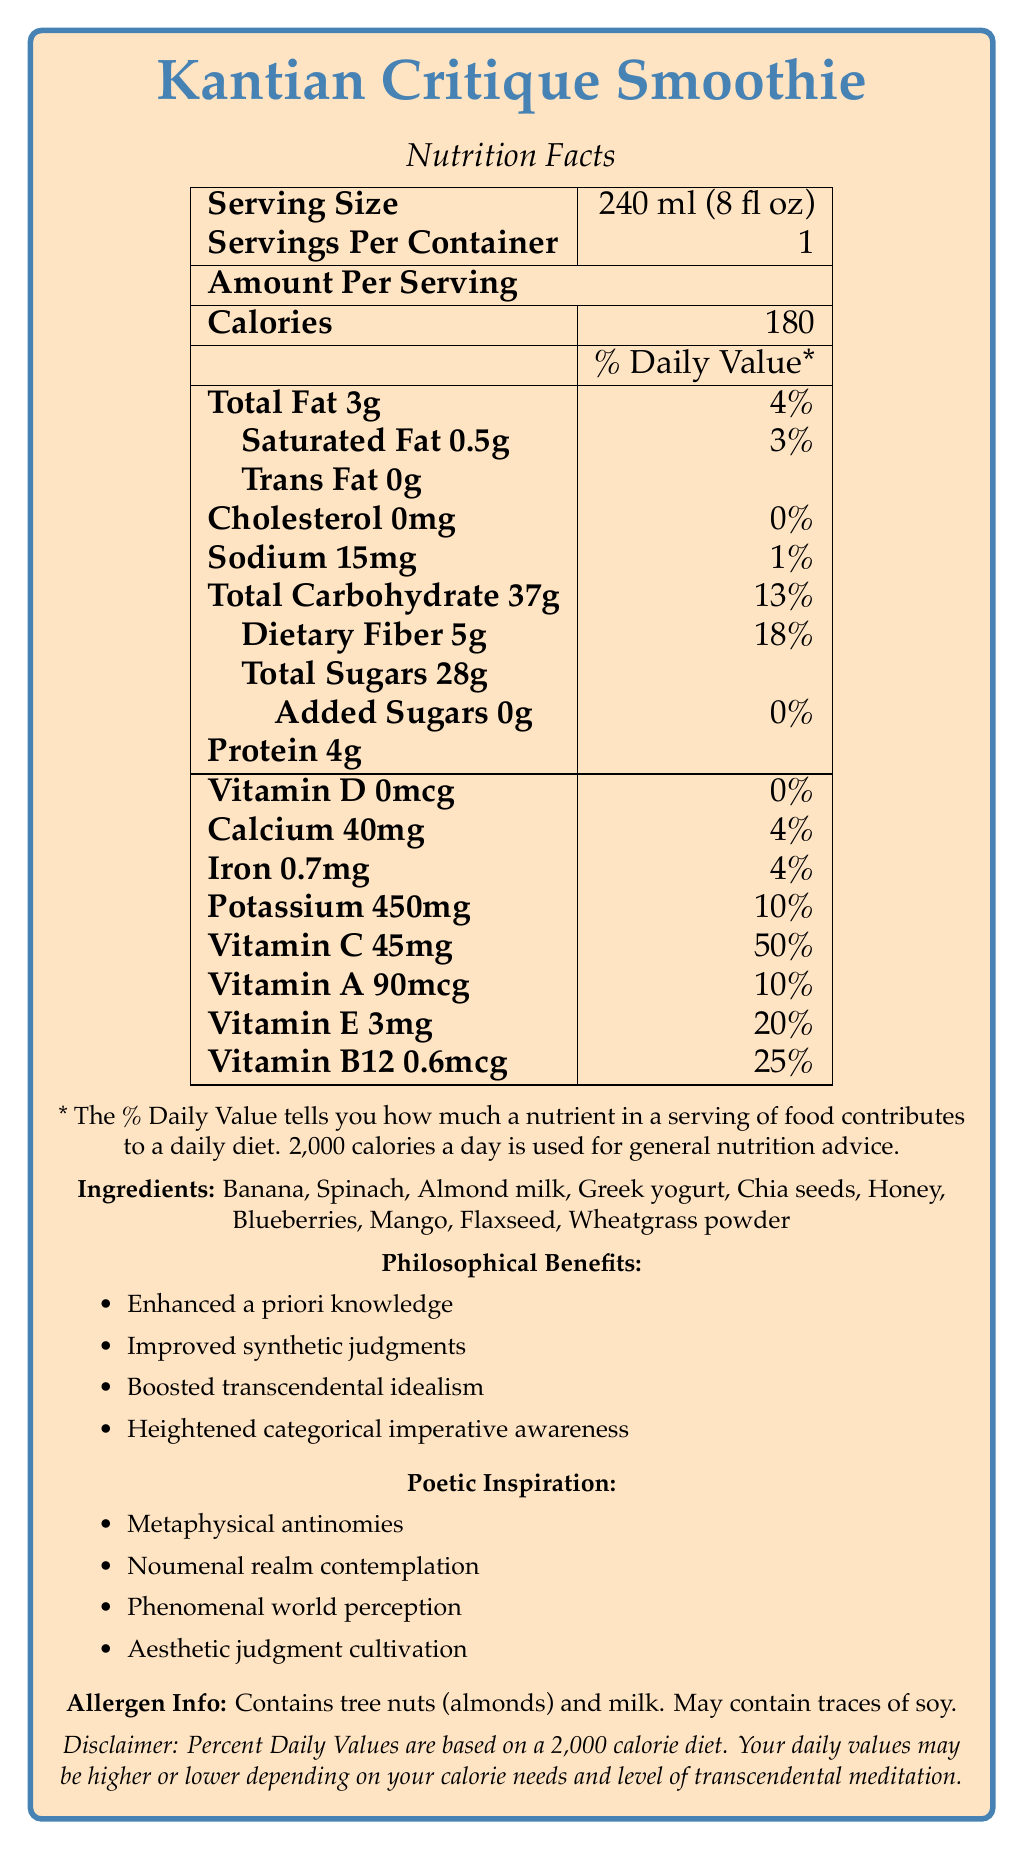What is the serving size of the Kantian Critique Smoothie? The serving size is explicitly listed at the top of the nutrition facts table as "Serving Size: 240 ml (8 fl oz)".
Answer: 240 ml (8 fl oz) How many calories are there per serving? The calories per serving are clearly stated in the nutrition facts as 180.
Answer: 180 Which ingredient contributes to the dietary fiber content? Both chia seeds and flaxseed are known to be high in dietary fiber, and they are listed in the ingredients.
Answer: Chia seeds, Flaxseed What is the daily value percentage of Vitamin C per serving? The daily value percentage of Vitamin C is stated as 50% in the nutrition facts.
Answer: 50% Does the smoothie contain any added sugars? The nutrition facts state the added sugars amount as "0g" and daily value as "0%", thus confirming there are no added sugars.
Answer: No Which of the following philosophical benefits is NOT provided by the Kantian Critique Smoothie? A. Enhanced a priori knowledge B. Improved synthetic judgments C. Boosted transcendental idealism D. Advanced empirical realism The document lists philosophical benefits, and "Advanced empirical realism" is not among them.
Answer: D How much protein is in the smoothie? A. 2g B. 4g C. 6g D. 8g The amount of protein per serving is listed as 4g in the nutrition facts.
Answer: B. 4g Does the Kantian Critique Smoothie contain tree nuts? The allergen info at the bottom explicitly states "Contains tree nuts (almonds)".
Answer: Yes Is the amount of total sugars in the smoothie higher than the dietary fiber content? The document states total sugars as 28g and dietary fiber as 5g, meaning total sugars are higher.
Answer: Yes Summarize the nutritional and philosophical benefits of the Kantian Critique Smoothie in one sentence. This concise summary captures both the caloric content, nutrients, and the distinct philosophical benefits listed in the document.
Answer: The Kantian Critique Smoothie provides 180 calories per serving, with significant vitamins and minerals, and offers philosophical benefits such as enhanced a priori knowledge and improved synthetic judgments. What is the source of Vitamin D in the smoothie? The document does not provide any information on the source of Vitamin D; it only lists the quantity as 0mcg and 0% daily value.
Answer: Not enough information 